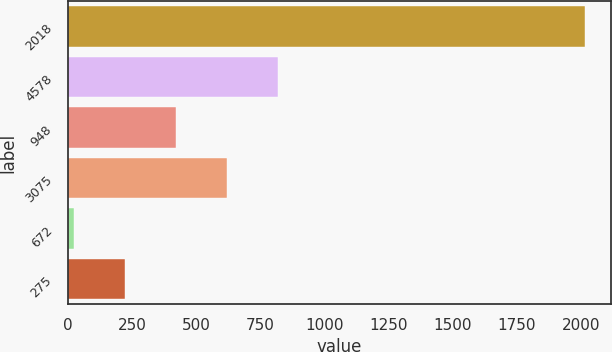Convert chart. <chart><loc_0><loc_0><loc_500><loc_500><bar_chart><fcel>2018<fcel>4578<fcel>948<fcel>3075<fcel>672<fcel>275<nl><fcel>2016<fcel>821.16<fcel>422.88<fcel>622.02<fcel>24.6<fcel>223.74<nl></chart> 